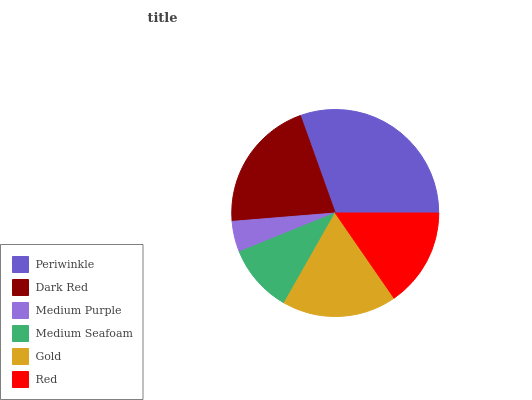Is Medium Purple the minimum?
Answer yes or no. Yes. Is Periwinkle the maximum?
Answer yes or no. Yes. Is Dark Red the minimum?
Answer yes or no. No. Is Dark Red the maximum?
Answer yes or no. No. Is Periwinkle greater than Dark Red?
Answer yes or no. Yes. Is Dark Red less than Periwinkle?
Answer yes or no. Yes. Is Dark Red greater than Periwinkle?
Answer yes or no. No. Is Periwinkle less than Dark Red?
Answer yes or no. No. Is Gold the high median?
Answer yes or no. Yes. Is Red the low median?
Answer yes or no. Yes. Is Medium Seafoam the high median?
Answer yes or no. No. Is Periwinkle the low median?
Answer yes or no. No. 